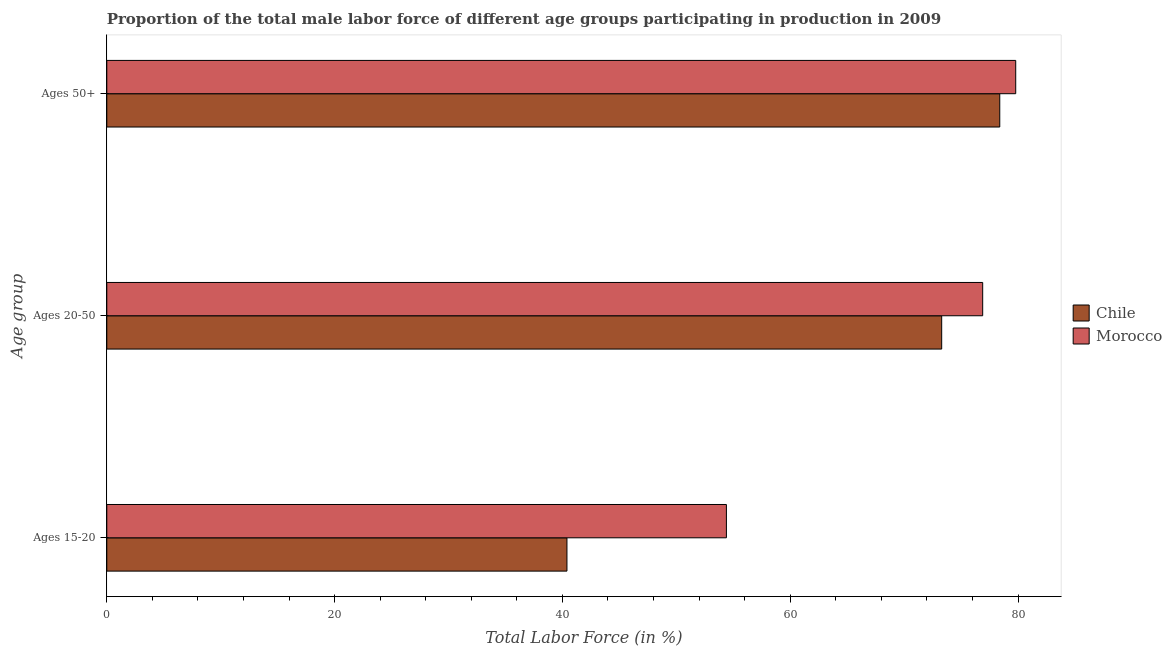How many different coloured bars are there?
Make the answer very short. 2. How many groups of bars are there?
Keep it short and to the point. 3. What is the label of the 1st group of bars from the top?
Your answer should be very brief. Ages 50+. What is the percentage of male labor force within the age group 20-50 in Chile?
Make the answer very short. 73.3. Across all countries, what is the maximum percentage of male labor force within the age group 20-50?
Make the answer very short. 76.9. Across all countries, what is the minimum percentage of male labor force within the age group 15-20?
Give a very brief answer. 40.4. In which country was the percentage of male labor force within the age group 20-50 maximum?
Make the answer very short. Morocco. What is the total percentage of male labor force within the age group 20-50 in the graph?
Give a very brief answer. 150.2. What is the difference between the percentage of male labor force above age 50 in Chile and that in Morocco?
Provide a succinct answer. -1.4. What is the difference between the percentage of male labor force within the age group 20-50 in Morocco and the percentage of male labor force within the age group 15-20 in Chile?
Keep it short and to the point. 36.5. What is the average percentage of male labor force above age 50 per country?
Give a very brief answer. 79.1. What is the difference between the percentage of male labor force within the age group 15-20 and percentage of male labor force above age 50 in Morocco?
Keep it short and to the point. -25.4. In how many countries, is the percentage of male labor force within the age group 15-20 greater than 72 %?
Your answer should be compact. 0. What is the ratio of the percentage of male labor force within the age group 15-20 in Chile to that in Morocco?
Offer a very short reply. 0.74. Is the percentage of male labor force within the age group 20-50 in Chile less than that in Morocco?
Provide a succinct answer. Yes. Is the difference between the percentage of male labor force within the age group 15-20 in Chile and Morocco greater than the difference between the percentage of male labor force within the age group 20-50 in Chile and Morocco?
Your response must be concise. No. What is the difference between the highest and the second highest percentage of male labor force within the age group 15-20?
Provide a short and direct response. 14. What is the difference between the highest and the lowest percentage of male labor force within the age group 20-50?
Provide a succinct answer. 3.6. What does the 2nd bar from the top in Ages 50+ represents?
Offer a terse response. Chile. What does the 1st bar from the bottom in Ages 50+ represents?
Your answer should be compact. Chile. Does the graph contain any zero values?
Your response must be concise. No. Does the graph contain grids?
Provide a short and direct response. No. How are the legend labels stacked?
Provide a short and direct response. Vertical. What is the title of the graph?
Your answer should be very brief. Proportion of the total male labor force of different age groups participating in production in 2009. Does "Australia" appear as one of the legend labels in the graph?
Offer a terse response. No. What is the label or title of the X-axis?
Your answer should be compact. Total Labor Force (in %). What is the label or title of the Y-axis?
Your answer should be compact. Age group. What is the Total Labor Force (in %) of Chile in Ages 15-20?
Offer a terse response. 40.4. What is the Total Labor Force (in %) in Morocco in Ages 15-20?
Offer a very short reply. 54.4. What is the Total Labor Force (in %) in Chile in Ages 20-50?
Provide a succinct answer. 73.3. What is the Total Labor Force (in %) of Morocco in Ages 20-50?
Give a very brief answer. 76.9. What is the Total Labor Force (in %) in Chile in Ages 50+?
Offer a terse response. 78.4. What is the Total Labor Force (in %) of Morocco in Ages 50+?
Offer a very short reply. 79.8. Across all Age group, what is the maximum Total Labor Force (in %) of Chile?
Keep it short and to the point. 78.4. Across all Age group, what is the maximum Total Labor Force (in %) of Morocco?
Your answer should be compact. 79.8. Across all Age group, what is the minimum Total Labor Force (in %) of Chile?
Your response must be concise. 40.4. Across all Age group, what is the minimum Total Labor Force (in %) in Morocco?
Offer a terse response. 54.4. What is the total Total Labor Force (in %) of Chile in the graph?
Your response must be concise. 192.1. What is the total Total Labor Force (in %) in Morocco in the graph?
Give a very brief answer. 211.1. What is the difference between the Total Labor Force (in %) of Chile in Ages 15-20 and that in Ages 20-50?
Offer a terse response. -32.9. What is the difference between the Total Labor Force (in %) in Morocco in Ages 15-20 and that in Ages 20-50?
Your answer should be compact. -22.5. What is the difference between the Total Labor Force (in %) of Chile in Ages 15-20 and that in Ages 50+?
Ensure brevity in your answer.  -38. What is the difference between the Total Labor Force (in %) in Morocco in Ages 15-20 and that in Ages 50+?
Your answer should be compact. -25.4. What is the difference between the Total Labor Force (in %) in Chile in Ages 20-50 and that in Ages 50+?
Your answer should be very brief. -5.1. What is the difference between the Total Labor Force (in %) in Morocco in Ages 20-50 and that in Ages 50+?
Your response must be concise. -2.9. What is the difference between the Total Labor Force (in %) of Chile in Ages 15-20 and the Total Labor Force (in %) of Morocco in Ages 20-50?
Provide a short and direct response. -36.5. What is the difference between the Total Labor Force (in %) in Chile in Ages 15-20 and the Total Labor Force (in %) in Morocco in Ages 50+?
Offer a terse response. -39.4. What is the difference between the Total Labor Force (in %) of Chile in Ages 20-50 and the Total Labor Force (in %) of Morocco in Ages 50+?
Your answer should be compact. -6.5. What is the average Total Labor Force (in %) of Chile per Age group?
Make the answer very short. 64.03. What is the average Total Labor Force (in %) of Morocco per Age group?
Give a very brief answer. 70.37. What is the difference between the Total Labor Force (in %) in Chile and Total Labor Force (in %) in Morocco in Ages 15-20?
Ensure brevity in your answer.  -14. What is the difference between the Total Labor Force (in %) in Chile and Total Labor Force (in %) in Morocco in Ages 20-50?
Your answer should be very brief. -3.6. What is the ratio of the Total Labor Force (in %) of Chile in Ages 15-20 to that in Ages 20-50?
Offer a very short reply. 0.55. What is the ratio of the Total Labor Force (in %) of Morocco in Ages 15-20 to that in Ages 20-50?
Provide a short and direct response. 0.71. What is the ratio of the Total Labor Force (in %) in Chile in Ages 15-20 to that in Ages 50+?
Keep it short and to the point. 0.52. What is the ratio of the Total Labor Force (in %) in Morocco in Ages 15-20 to that in Ages 50+?
Provide a short and direct response. 0.68. What is the ratio of the Total Labor Force (in %) of Chile in Ages 20-50 to that in Ages 50+?
Your answer should be very brief. 0.93. What is the ratio of the Total Labor Force (in %) in Morocco in Ages 20-50 to that in Ages 50+?
Offer a very short reply. 0.96. What is the difference between the highest and the second highest Total Labor Force (in %) of Chile?
Provide a succinct answer. 5.1. What is the difference between the highest and the second highest Total Labor Force (in %) in Morocco?
Offer a very short reply. 2.9. What is the difference between the highest and the lowest Total Labor Force (in %) in Morocco?
Make the answer very short. 25.4. 